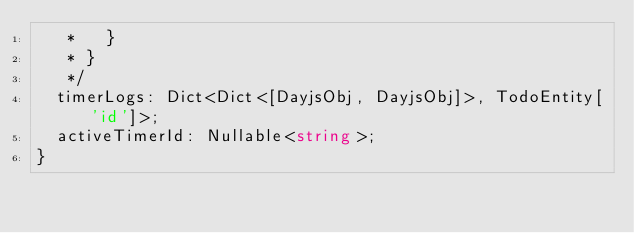<code> <loc_0><loc_0><loc_500><loc_500><_TypeScript_>   *   }
   * }
   */
  timerLogs: Dict<Dict<[DayjsObj, DayjsObj]>, TodoEntity['id']>;
  activeTimerId: Nullable<string>;
}
</code> 